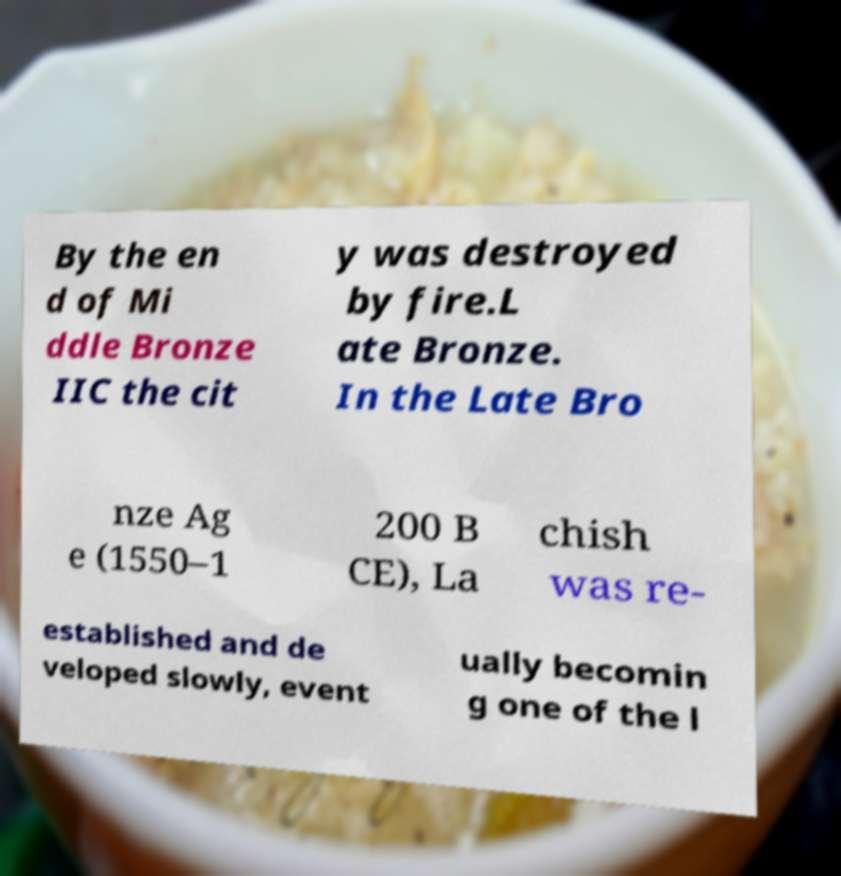I need the written content from this picture converted into text. Can you do that? By the en d of Mi ddle Bronze IIC the cit y was destroyed by fire.L ate Bronze. In the Late Bro nze Ag e (1550–1 200 B CE), La chish was re- established and de veloped slowly, event ually becomin g one of the l 